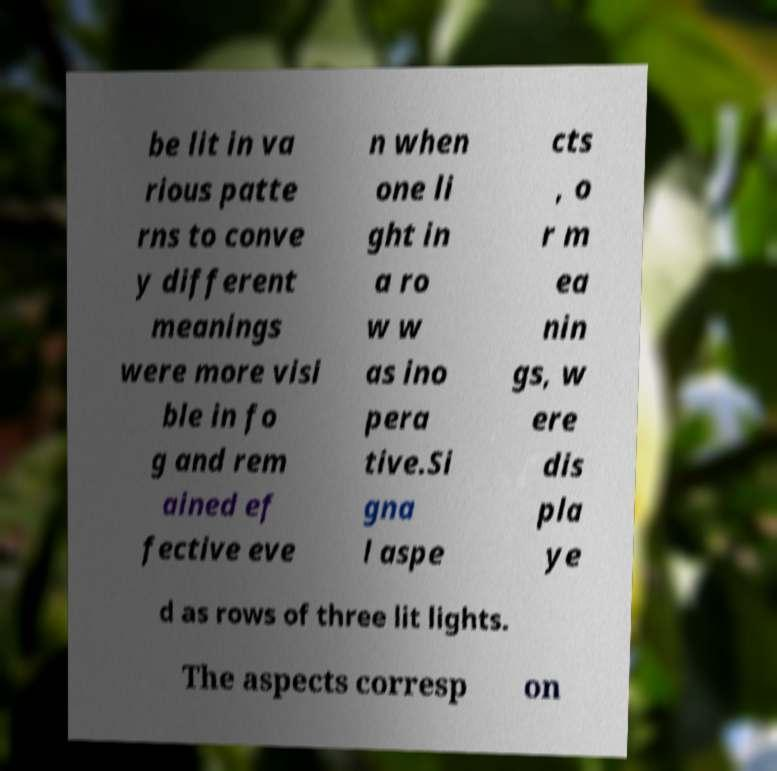I need the written content from this picture converted into text. Can you do that? be lit in va rious patte rns to conve y different meanings were more visi ble in fo g and rem ained ef fective eve n when one li ght in a ro w w as ino pera tive.Si gna l aspe cts , o r m ea nin gs, w ere dis pla ye d as rows of three lit lights. The aspects corresp on 